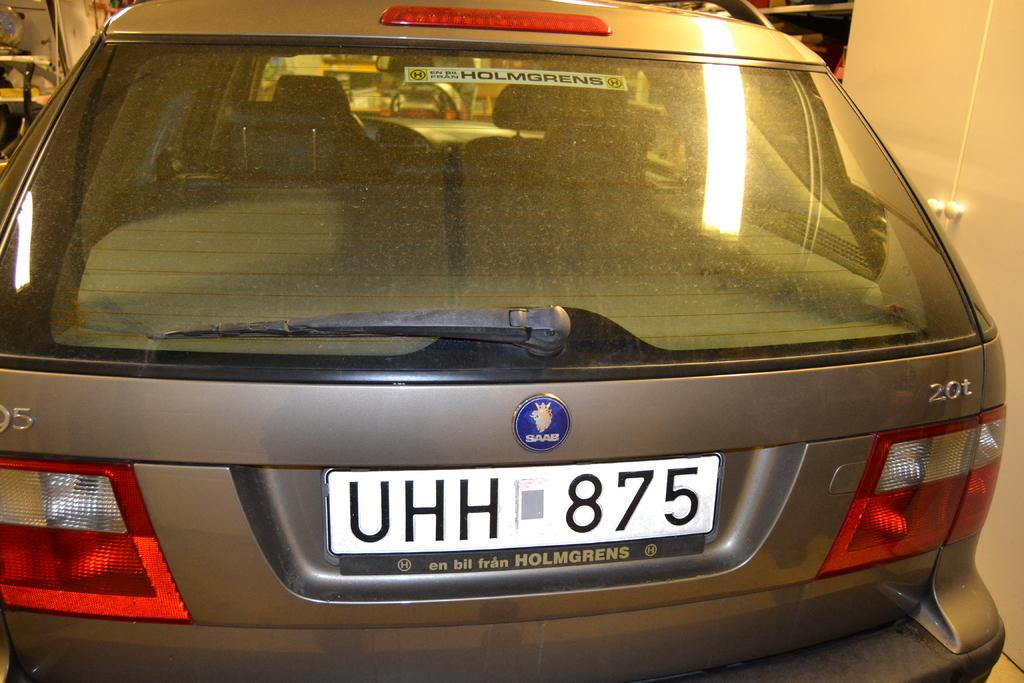What is the license plate number?
Your response must be concise. Uhh 875. What is the tag number?
Provide a short and direct response. Uhh 875. 